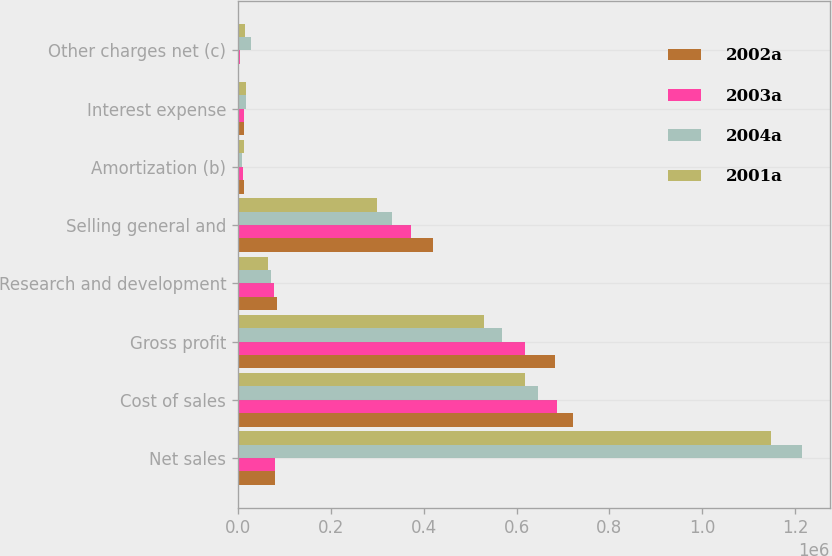Convert chart to OTSL. <chart><loc_0><loc_0><loc_500><loc_500><stacked_bar_chart><ecel><fcel>Net sales<fcel>Cost of sales<fcel>Gross profit<fcel>Research and development<fcel>Selling general and<fcel>Amortization (b)<fcel>Interest expense<fcel>Other charges net (c)<nl><fcel>2002a<fcel>80610<fcel>722047<fcel>682407<fcel>83217<fcel>419780<fcel>12256<fcel>12888<fcel>42<nl><fcel>2003a<fcel>80610<fcel>686255<fcel>618176<fcel>78003<fcel>372822<fcel>11724<fcel>14153<fcel>4563<nl><fcel>2004a<fcel>1.21371e+06<fcel>645970<fcel>567737<fcel>70625<fcel>331959<fcel>9332<fcel>17209<fcel>28202<nl><fcel>2001a<fcel>1.14802e+06<fcel>619140<fcel>528882<fcel>64627<fcel>299191<fcel>14114<fcel>17162<fcel>15354<nl></chart> 